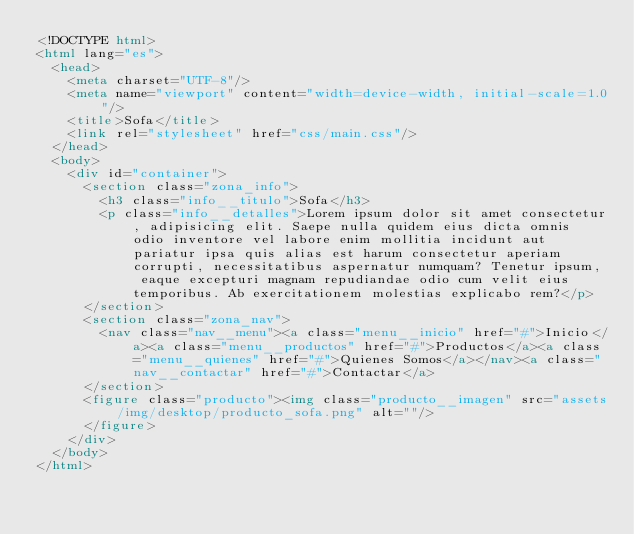Convert code to text. <code><loc_0><loc_0><loc_500><loc_500><_HTML_><!DOCTYPE html>
<html lang="es">
  <head>
    <meta charset="UTF-8"/>
    <meta name="viewport" content="width=device-width, initial-scale=1.0"/>
    <title>Sofa</title>
    <link rel="stylesheet" href="css/main.css"/>
  </head>
  <body>
    <div id="container">
      <section class="zona_info">
        <h3 class="info__titulo">Sofa</h3>
        <p class="info__detalles">Lorem ipsum dolor sit amet consectetur, adipisicing elit. Saepe nulla quidem eius dicta omnis odio inventore vel labore enim mollitia incidunt aut pariatur ipsa quis alias est harum consectetur aperiam corrupti, necessitatibus aspernatur numquam? Tenetur ipsum, eaque excepturi magnam repudiandae odio cum velit eius temporibus. Ab exercitationem molestias explicabo rem?</p>
      </section>
      <section class="zona_nav">
        <nav class="nav__menu"><a class="menu__inicio" href="#">Inicio</a><a class="menu__productos" href="#">Productos</a><a class="menu__quienes" href="#">Quienes Somos</a></nav><a class="nav__contactar" href="#">Contactar</a>
      </section>
      <figure class="producto"><img class="producto__imagen" src="assets/img/desktop/producto_sofa.png" alt=""/>
      </figure>
    </div>
  </body>
</html></code> 